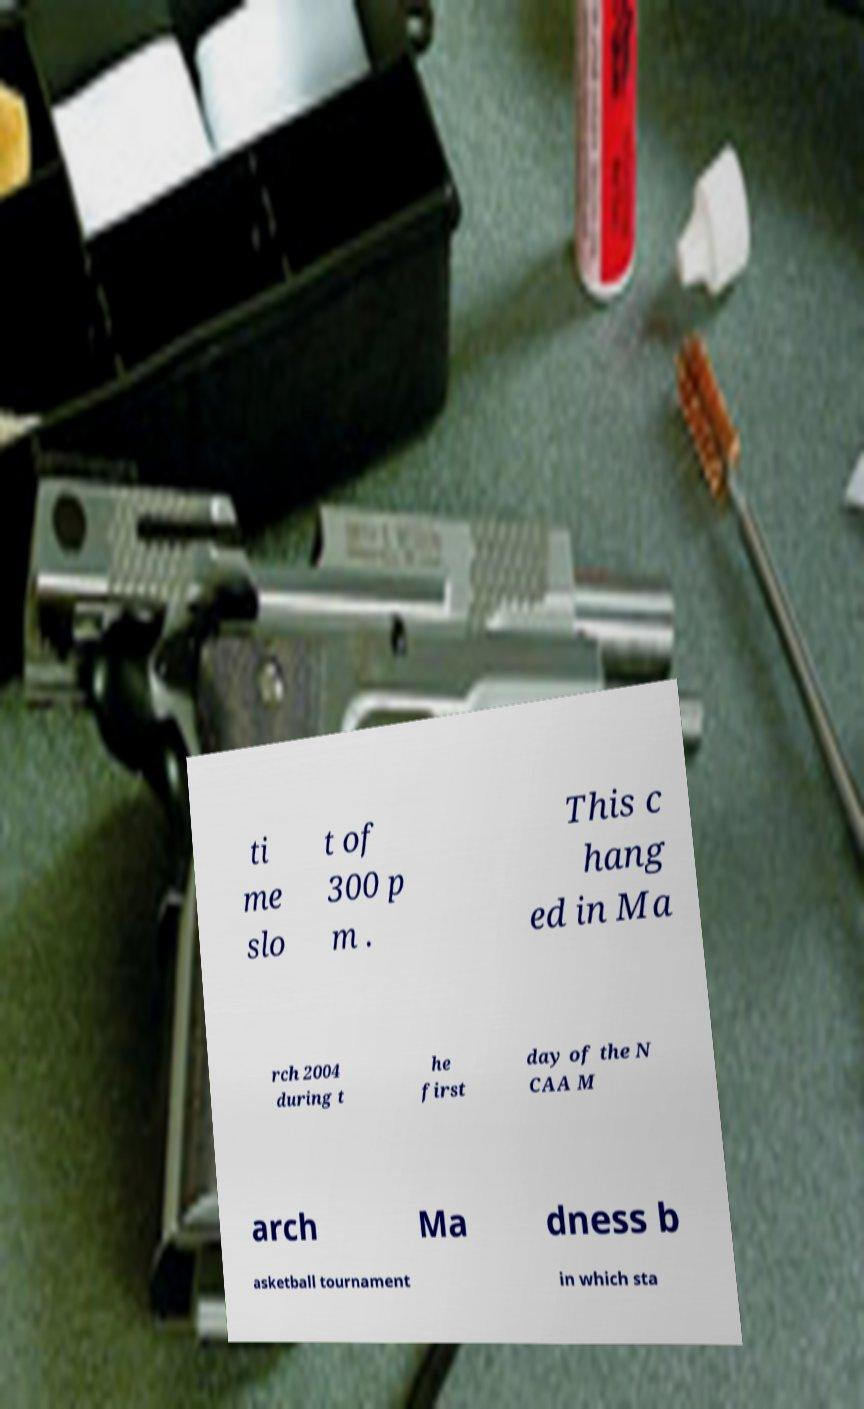What messages or text are displayed in this image? I need them in a readable, typed format. ti me slo t of 300 p m . This c hang ed in Ma rch 2004 during t he first day of the N CAA M arch Ma dness b asketball tournament in which sta 